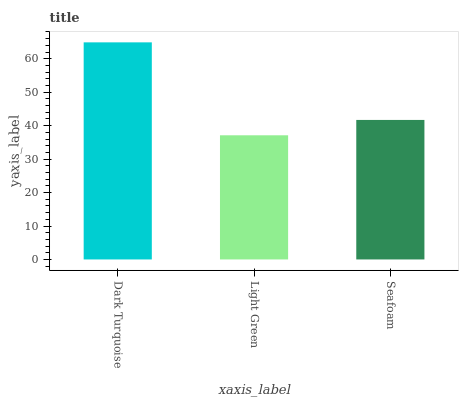Is Light Green the minimum?
Answer yes or no. Yes. Is Dark Turquoise the maximum?
Answer yes or no. Yes. Is Seafoam the minimum?
Answer yes or no. No. Is Seafoam the maximum?
Answer yes or no. No. Is Seafoam greater than Light Green?
Answer yes or no. Yes. Is Light Green less than Seafoam?
Answer yes or no. Yes. Is Light Green greater than Seafoam?
Answer yes or no. No. Is Seafoam less than Light Green?
Answer yes or no. No. Is Seafoam the high median?
Answer yes or no. Yes. Is Seafoam the low median?
Answer yes or no. Yes. Is Dark Turquoise the high median?
Answer yes or no. No. Is Dark Turquoise the low median?
Answer yes or no. No. 